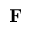Convert formula to latex. <formula><loc_0><loc_0><loc_500><loc_500>{ F }</formula> 